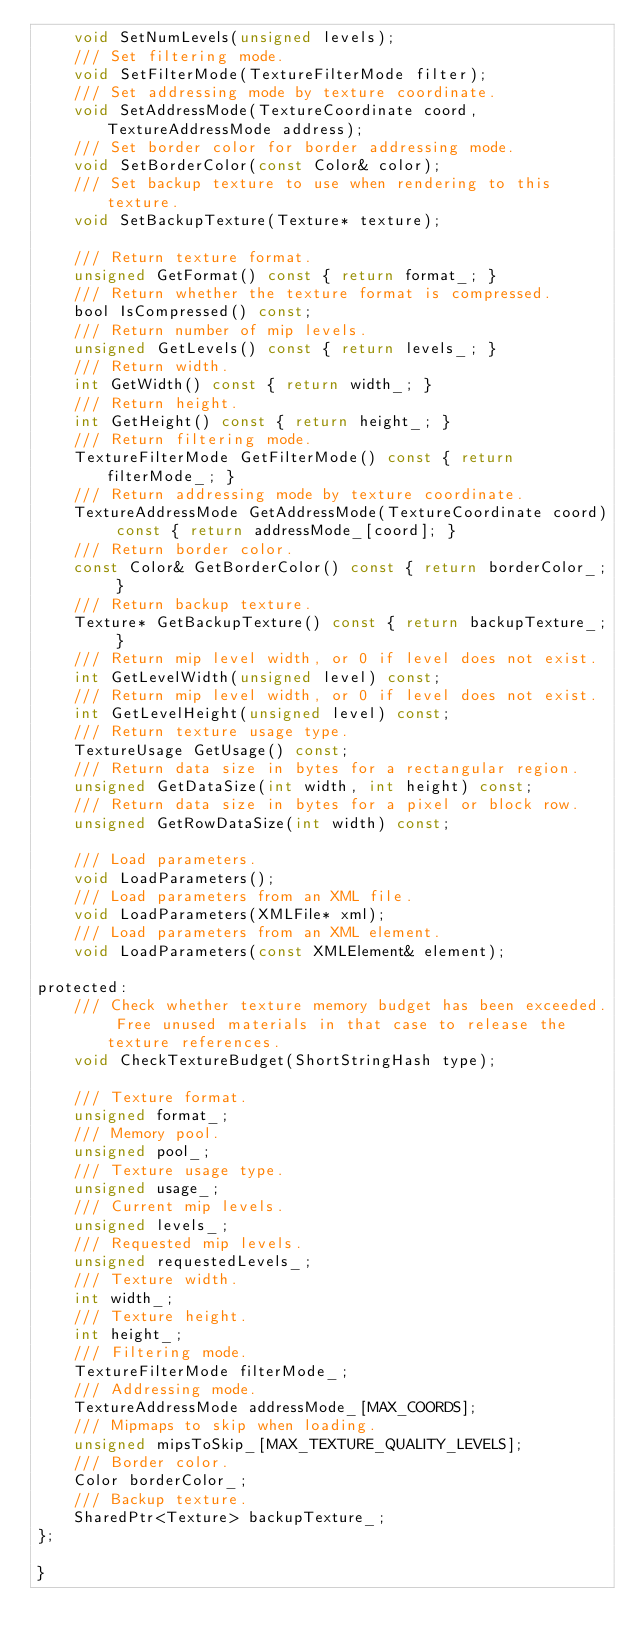<code> <loc_0><loc_0><loc_500><loc_500><_C_>    void SetNumLevels(unsigned levels);
    /// Set filtering mode.
    void SetFilterMode(TextureFilterMode filter);
    /// Set addressing mode by texture coordinate.
    void SetAddressMode(TextureCoordinate coord, TextureAddressMode address);
    /// Set border color for border addressing mode.
    void SetBorderColor(const Color& color);
    /// Set backup texture to use when rendering to this texture.
    void SetBackupTexture(Texture* texture);
    
    /// Return texture format.
    unsigned GetFormat() const { return format_; }
    /// Return whether the texture format is compressed.
    bool IsCompressed() const;
    /// Return number of mip levels.
    unsigned GetLevels() const { return levels_; }
    /// Return width.
    int GetWidth() const { return width_; }
    /// Return height.
    int GetHeight() const { return height_; }
    /// Return filtering mode.
    TextureFilterMode GetFilterMode() const { return filterMode_; }
    /// Return addressing mode by texture coordinate.
    TextureAddressMode GetAddressMode(TextureCoordinate coord) const { return addressMode_[coord]; }
    /// Return border color.
    const Color& GetBorderColor() const { return borderColor_; }
    /// Return backup texture.
    Texture* GetBackupTexture() const { return backupTexture_; }
    /// Return mip level width, or 0 if level does not exist.
    int GetLevelWidth(unsigned level) const;
    /// Return mip level width, or 0 if level does not exist.
    int GetLevelHeight(unsigned level) const;
    /// Return texture usage type.
    TextureUsage GetUsage() const;
    /// Return data size in bytes for a rectangular region.
    unsigned GetDataSize(int width, int height) const;
    /// Return data size in bytes for a pixel or block row.
    unsigned GetRowDataSize(int width) const;
    
    /// Load parameters.
    void LoadParameters();
    /// Load parameters from an XML file.
    void LoadParameters(XMLFile* xml);
    /// Load parameters from an XML element.
    void LoadParameters(const XMLElement& element);
    
protected:
    /// Check whether texture memory budget has been exceeded. Free unused materials in that case to release the texture references.
    void CheckTextureBudget(ShortStringHash type);
    
    /// Texture format.
    unsigned format_;
    /// Memory pool.
    unsigned pool_;
    /// Texture usage type.
    unsigned usage_;
    /// Current mip levels.
    unsigned levels_;
    /// Requested mip levels.
    unsigned requestedLevels_;
    /// Texture width.
    int width_;
    /// Texture height.
    int height_;
    /// Filtering mode.
    TextureFilterMode filterMode_;
    /// Addressing mode.
    TextureAddressMode addressMode_[MAX_COORDS];
    /// Mipmaps to skip when loading.
    unsigned mipsToSkip_[MAX_TEXTURE_QUALITY_LEVELS];
    /// Border color.
    Color borderColor_;
    /// Backup texture.
    SharedPtr<Texture> backupTexture_;
};

}
</code> 